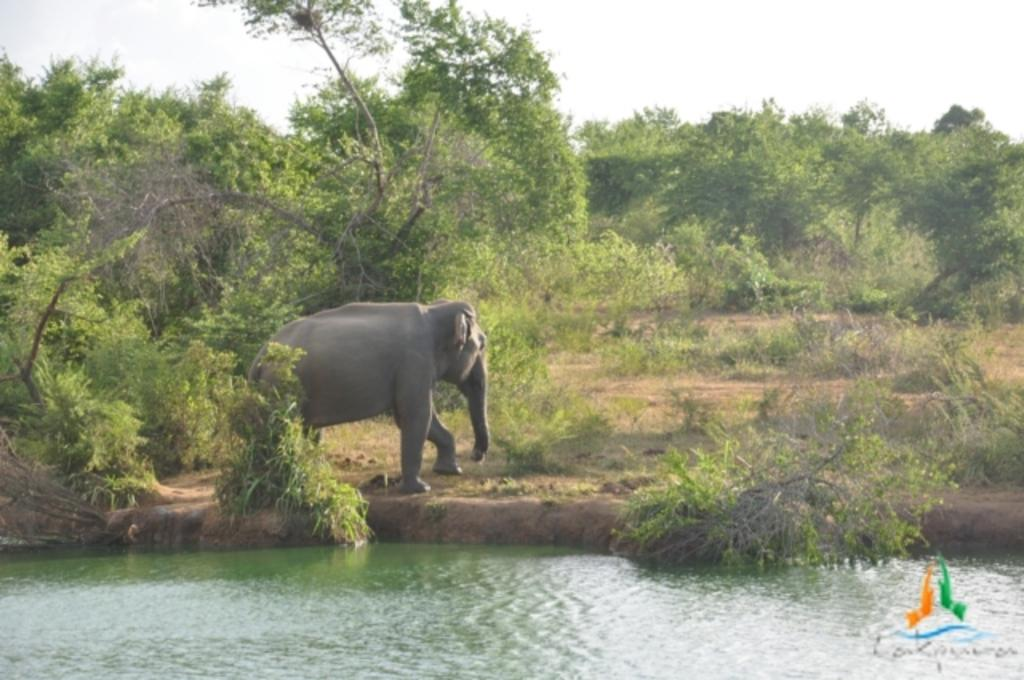What is present in the picture? There is water, plants, an elephant, trees, and the sky visible in the background of the picture. Can you describe the elephant in the picture? There is an elephant standing in the picture. What type of vegetation can be seen in the picture? There are plants and trees in the picture. What is visible in the background of the picture? The sky is visible in the background of the picture. What type of card game is being played by the elephant in the picture? There is no card game or any indication of playing cards in the image; it features an elephant standing near water and plants. Can you describe the ray that is swimming with the elephant in the picture? There is no ray present in the image; it only features an elephant, water, plants, trees, and the sky. 